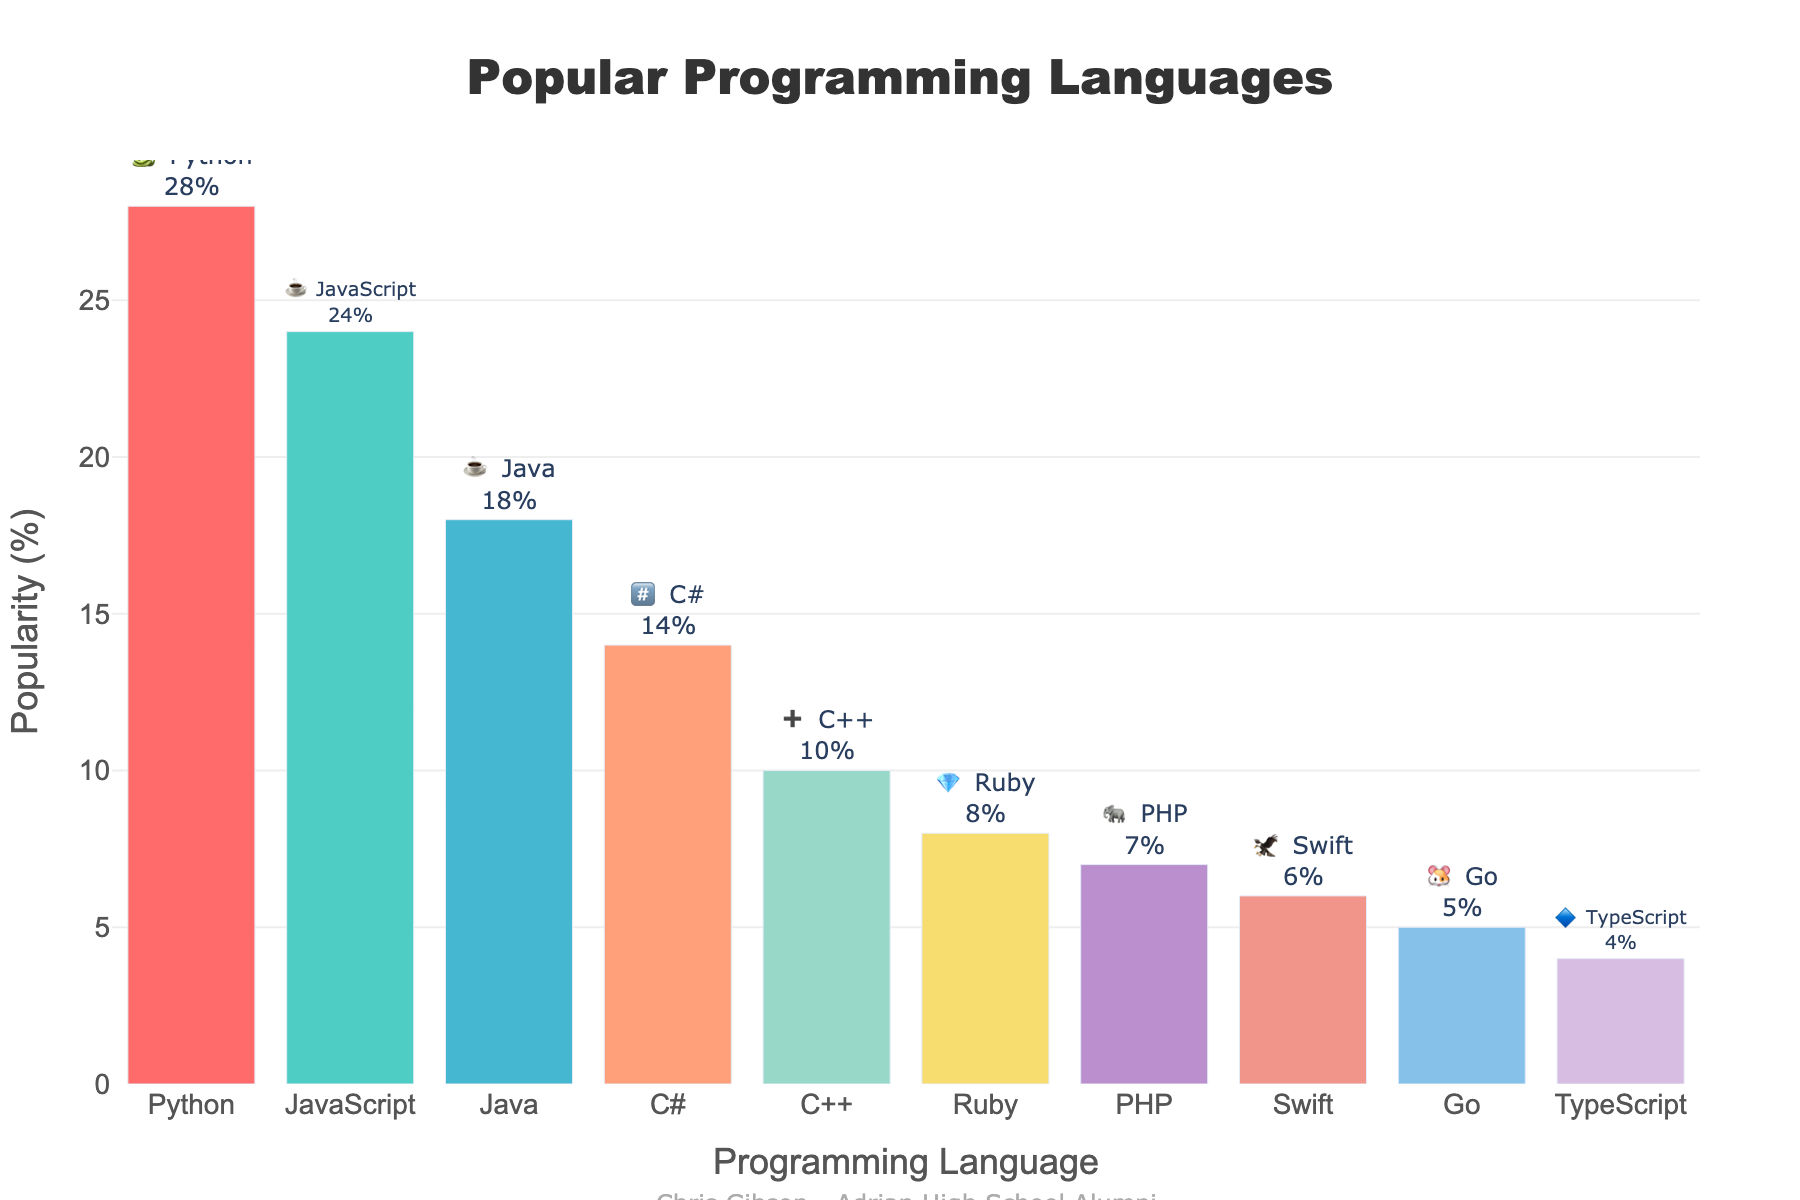What's the most popular programming language? The chart shows the popularity percentages of different programming languages. The highest bar represents Python with 28% popularity.
Answer: Python Which programming languages have equal popularity and what is their percentage? Look at the heights of the bars and their labels. Both JavaScript and Java have the same emoji (☕) and equal popularity, with JavaScript at 24% and Java at 18%. Each language is identified by its unique emoji as well.
Answer: None What is the total popularity of JavaScript and PHP combined? From the chart, JavaScript has a popularity of 24% and PHP has 7%. Adding these values together: 24% + 7% = 31%.
Answer: 31% Which language is less popular, C++ or Ruby? Comparing the bars for C++ and Ruby, C++ has a popularity of 10%, while Ruby has 8%. Ruby is less popular than C++.
Answer: Ruby How many programming languages have a popularity of 10% or higher? Count the bars with a labeled percentage of 10% or higher. There are six languages with such values: Python (28%), JavaScript (24%), Java (18%), C# (14%), C++ (10%), and Ruby (8%).
Answer: 5 What percentage is Swift less popular than Python? From the chart, Python has a popularity of 28% and Swift has 6%. Subtract Swift's popularity from Python's: 28% - 6% = 22%.
Answer: 22% What is the average popularity percentage of the top three programming languages? The top three languages are Python (28%), JavaScript (24%), and Java (18%). Calculate the average: (28 + 24 + 18) / 3 = 70 / 3 ≈ 23.33%.
Answer: 23.33% Compare the popularity between TypeScript and Go. Which is more popular? From the chart, Go has a popularity of 5%, while TypeScript has 4%. Go is more popular than TypeScript.
Answer: Go What two languages have similar popularity but different emojis, and what is their percentage difference? C++ (10%) and Ruby (8%) have close popularity but different emojis (➕ for C++ and 💎 for Ruby). The percentage difference is 10% - 8% = 2%.
Answer: C++ and Ruby, 2% What is the total popularity percentage of all languages combined? Sum the popularity percentages of all bars: 28% + 24% + 18% + 14% + 10% + 8% + 7% + 6% + 5% + 4% = 124%.
Answer: 124% 